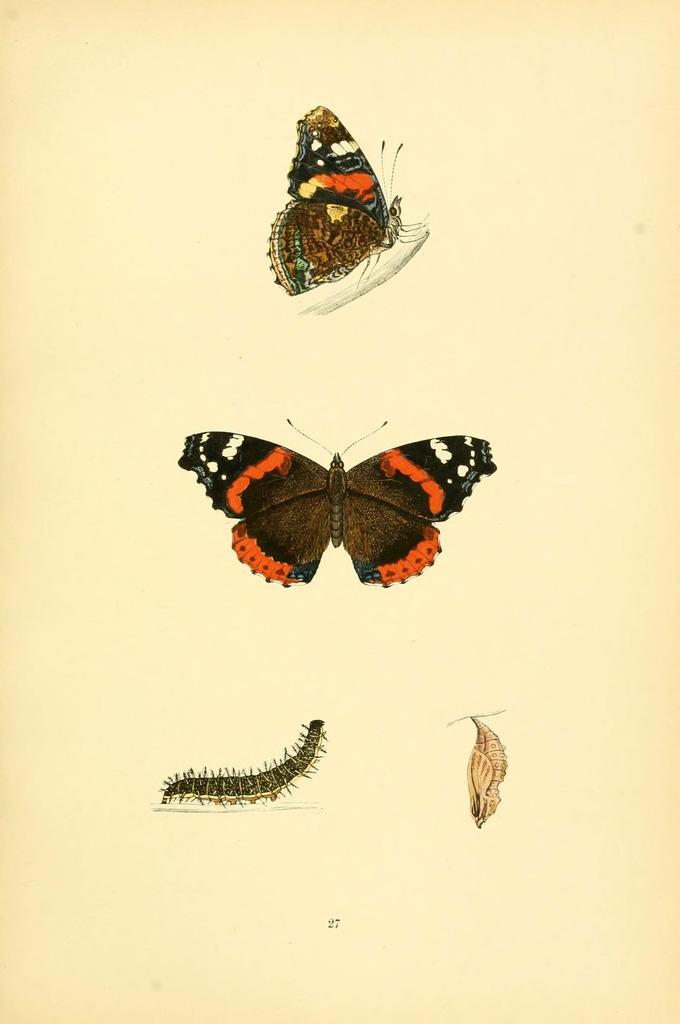Can you describe this image briefly? In this image I can see the drawing of few insects on the paper. I can see these insects are in red, black, brown and white color. 